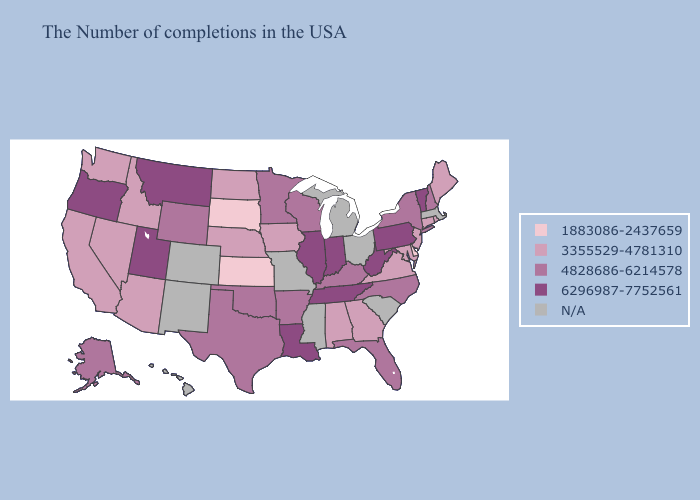Does Wisconsin have the lowest value in the USA?
Write a very short answer. No. Does New York have the lowest value in the Northeast?
Short answer required. No. Among the states that border Iowa , does South Dakota have the lowest value?
Write a very short answer. Yes. Does the map have missing data?
Short answer required. Yes. Does Wyoming have the lowest value in the West?
Answer briefly. No. Is the legend a continuous bar?
Answer briefly. No. What is the value of Washington?
Quick response, please. 3355529-4781310. Does New Hampshire have the lowest value in the USA?
Keep it brief. No. Name the states that have a value in the range 1883086-2437659?
Keep it brief. Delaware, Kansas, South Dakota. How many symbols are there in the legend?
Concise answer only. 5. What is the lowest value in the USA?
Quick response, please. 1883086-2437659. Among the states that border Kansas , does Oklahoma have the highest value?
Quick response, please. Yes. Name the states that have a value in the range N/A?
Write a very short answer. Massachusetts, South Carolina, Ohio, Michigan, Mississippi, Missouri, Colorado, New Mexico, Hawaii. 